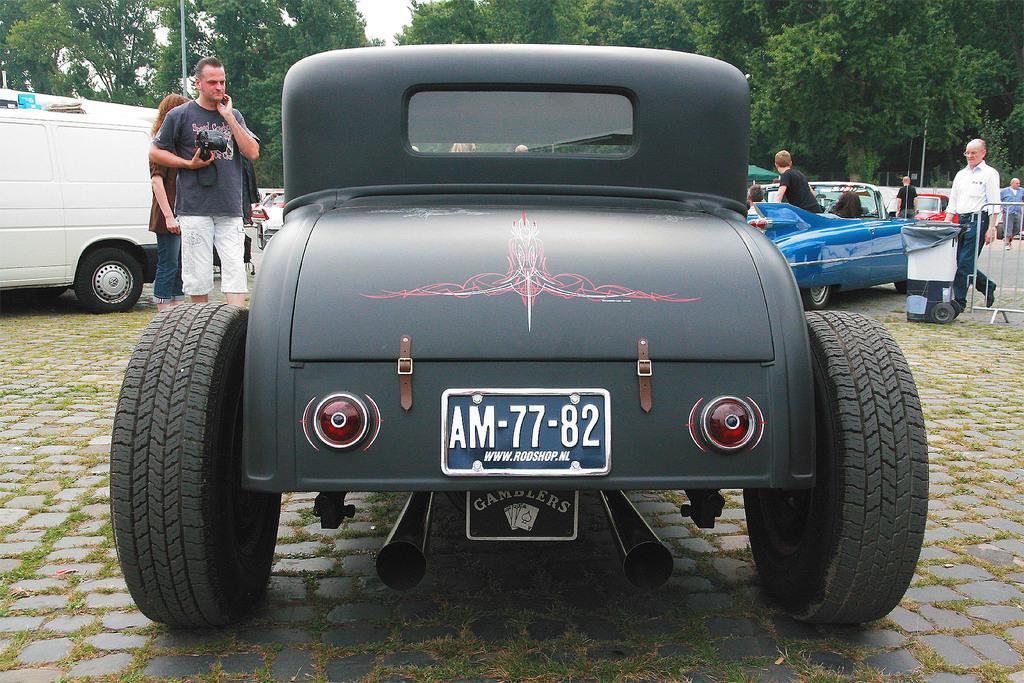How would you summarize this image in a sentence or two? In this picture there are vehicles. In the foreground there is text on the vehicle. On the left side of the image there is a man standing and holding the object and there is a woman standing. On the right side of the image there are two people walking behind the railing and there is a dustbin. At the back there are group of people and there are trees and poles. At the top there is sky. At the bottom there is a pavement and there is grass and there is a road. 